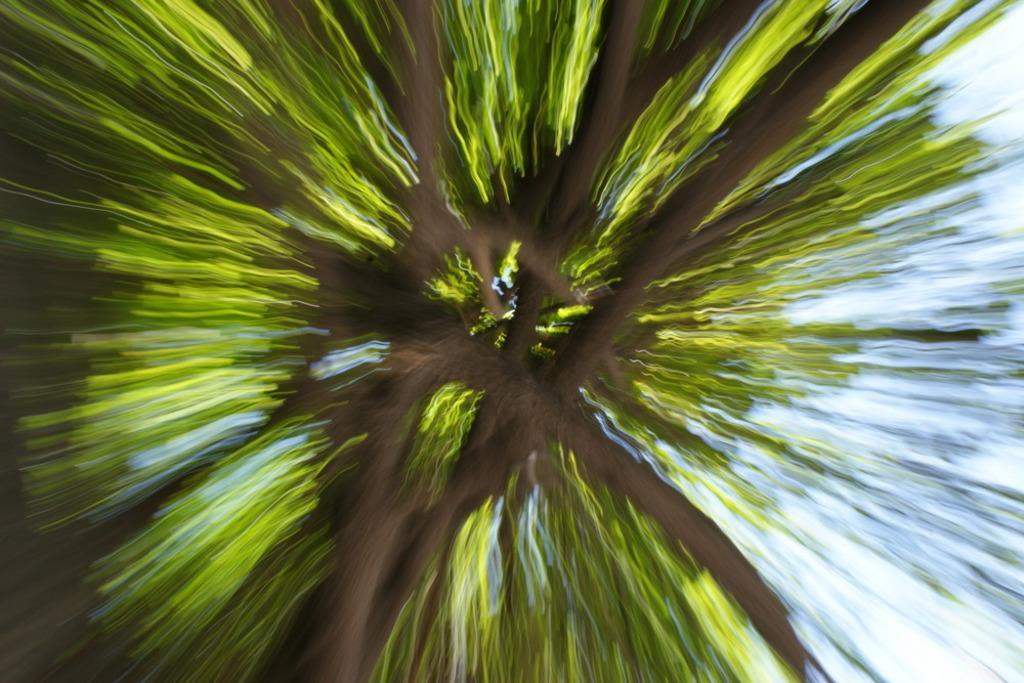Please provide a concise description of this image. In this image I can see the tree and the sky. I can see the image is blurred. 